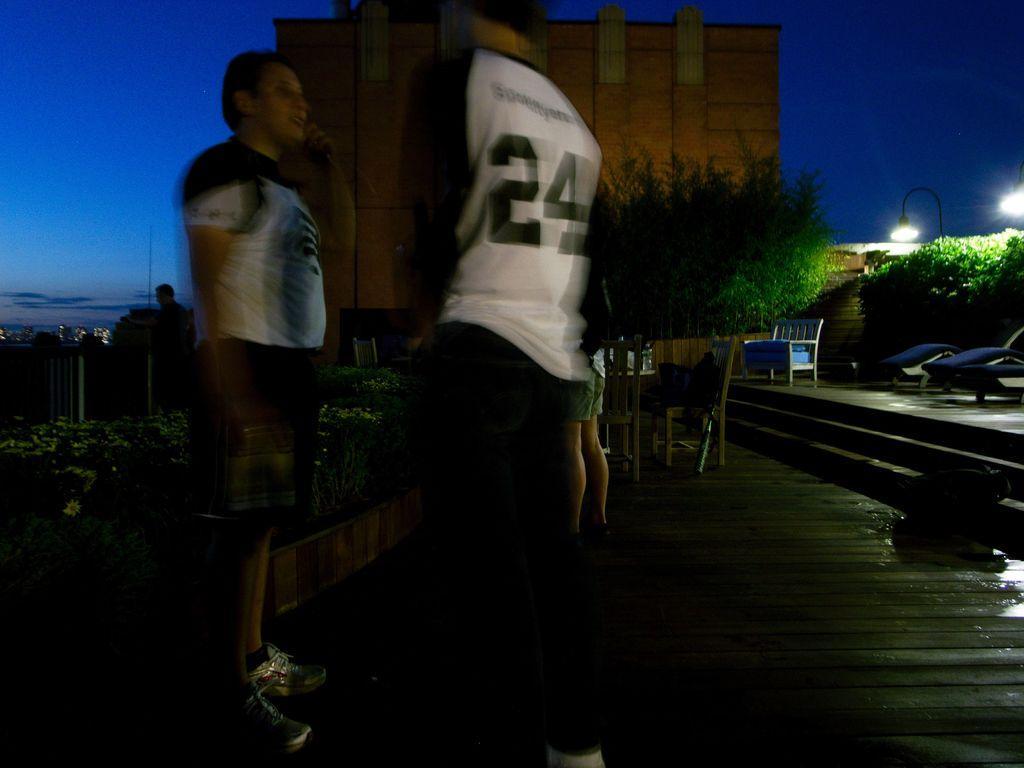Can you describe this image briefly? In this picture there are two men wearing same dress. Both of them are standing near to the water. On the right we can see bed and bench near to the plants and street light. In the background we can see building and trees. On the top left corner there is a sky. Here can see buildings, lights and poles. 